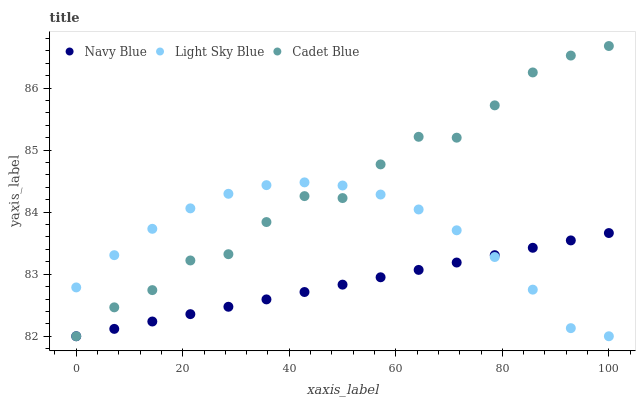Does Navy Blue have the minimum area under the curve?
Answer yes or no. Yes. Does Cadet Blue have the maximum area under the curve?
Answer yes or no. Yes. Does Light Sky Blue have the minimum area under the curve?
Answer yes or no. No. Does Light Sky Blue have the maximum area under the curve?
Answer yes or no. No. Is Navy Blue the smoothest?
Answer yes or no. Yes. Is Cadet Blue the roughest?
Answer yes or no. Yes. Is Light Sky Blue the smoothest?
Answer yes or no. No. Is Light Sky Blue the roughest?
Answer yes or no. No. Does Cadet Blue have the lowest value?
Answer yes or no. Yes. Does Cadet Blue have the highest value?
Answer yes or no. Yes. Does Light Sky Blue have the highest value?
Answer yes or no. No. Does Cadet Blue intersect Navy Blue?
Answer yes or no. Yes. Is Cadet Blue less than Navy Blue?
Answer yes or no. No. Is Cadet Blue greater than Navy Blue?
Answer yes or no. No. 